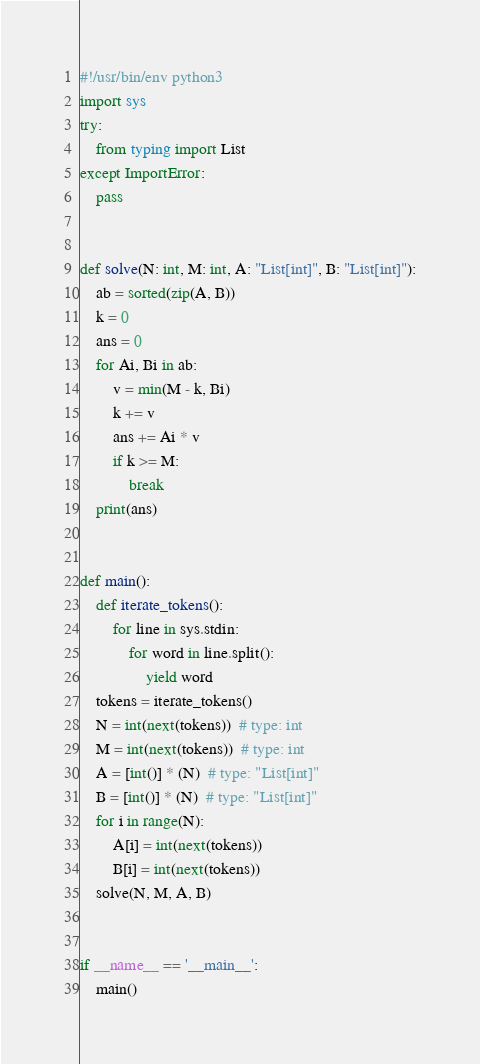Convert code to text. <code><loc_0><loc_0><loc_500><loc_500><_Python_>#!/usr/bin/env python3
import sys
try:
    from typing import List
except ImportError:
    pass


def solve(N: int, M: int, A: "List[int]", B: "List[int]"):
    ab = sorted(zip(A, B))
    k = 0
    ans = 0
    for Ai, Bi in ab:
        v = min(M - k, Bi)
        k += v
        ans += Ai * v
        if k >= M:
            break
    print(ans)


def main():
    def iterate_tokens():
        for line in sys.stdin:
            for word in line.split():
                yield word
    tokens = iterate_tokens()
    N = int(next(tokens))  # type: int
    M = int(next(tokens))  # type: int
    A = [int()] * (N)  # type: "List[int]"
    B = [int()] * (N)  # type: "List[int]"
    for i in range(N):
        A[i] = int(next(tokens))
        B[i] = int(next(tokens))
    solve(N, M, A, B)


if __name__ == '__main__':
    main()
</code> 